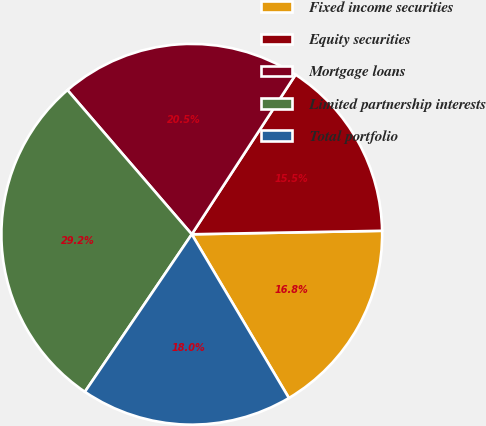Convert chart to OTSL. <chart><loc_0><loc_0><loc_500><loc_500><pie_chart><fcel>Fixed income securities<fcel>Equity securities<fcel>Mortgage loans<fcel>Limited partnership interests<fcel>Total portfolio<nl><fcel>16.77%<fcel>15.53%<fcel>20.5%<fcel>29.19%<fcel>18.01%<nl></chart> 